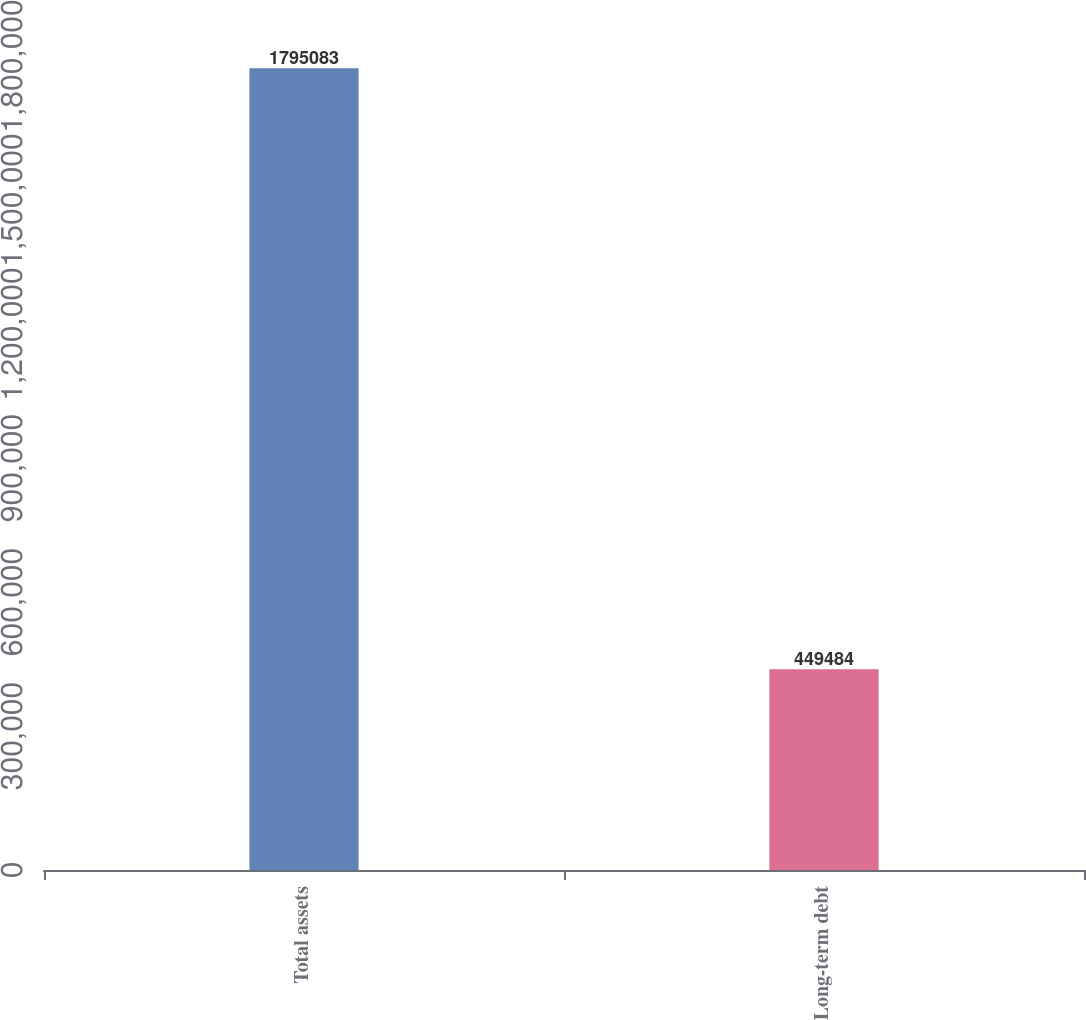Convert chart. <chart><loc_0><loc_0><loc_500><loc_500><bar_chart><fcel>Total assets<fcel>Long-term debt<nl><fcel>1.79508e+06<fcel>449484<nl></chart> 